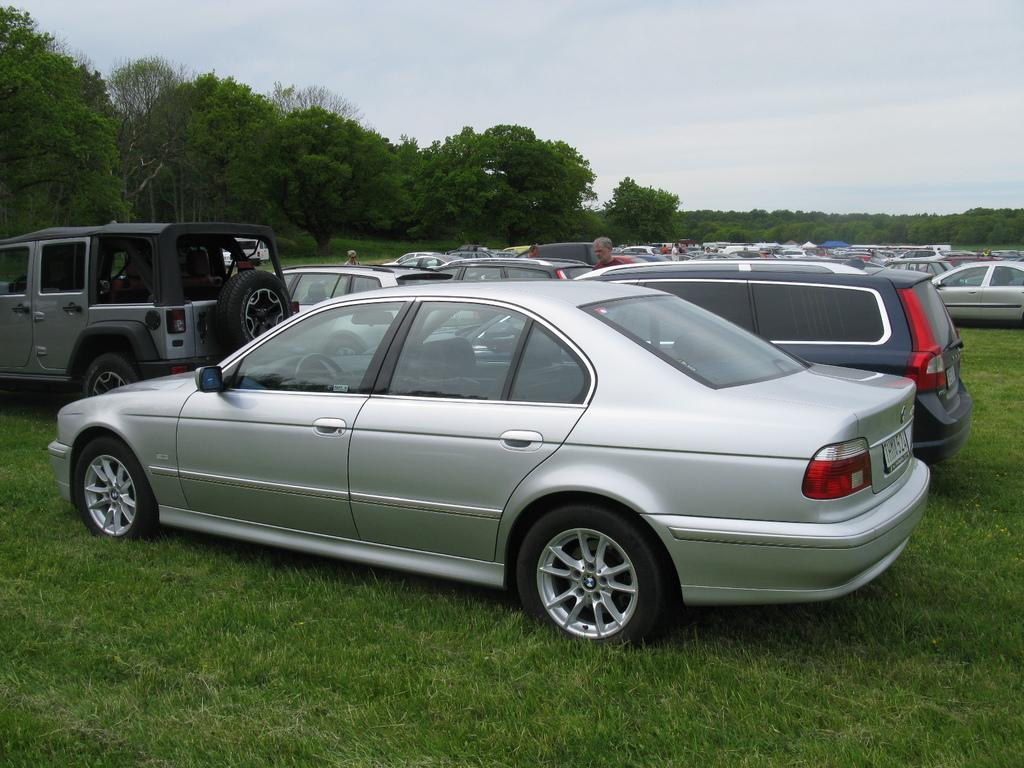What can be seen in the image related to vehicles? There are different types of cars in the image. What is the status of the cars in the image? The cars are parked. What type of natural environment is visible in the image? There is grass visible in the image, as well as trees with branches and leaves. What part of the sky is visible in the image? The sky is visible in the image. Is there any human presence in the image? Yes, there is a person standing in the image. What type of mailbox does the person's dad regret buying in the image? There is no mention of a mailbox or the person's dad in the image, so this question cannot be answered. 